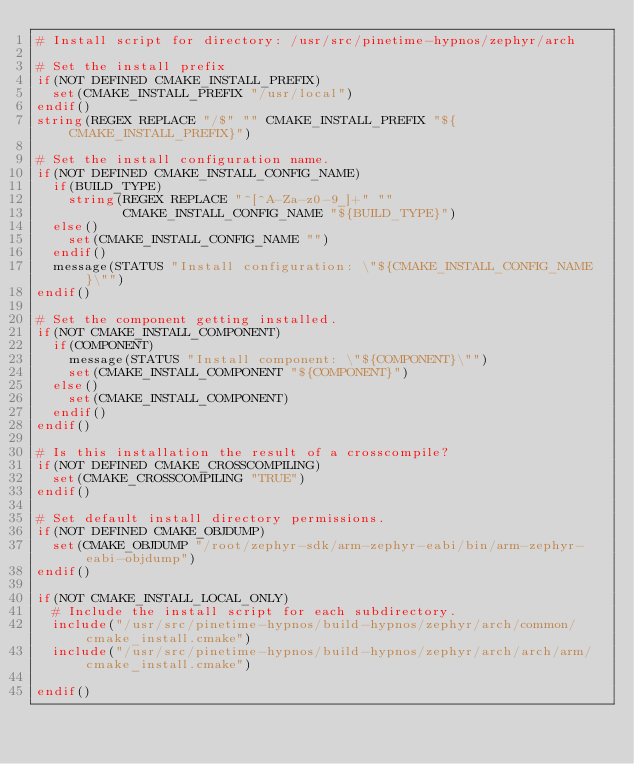<code> <loc_0><loc_0><loc_500><loc_500><_CMake_># Install script for directory: /usr/src/pinetime-hypnos/zephyr/arch

# Set the install prefix
if(NOT DEFINED CMAKE_INSTALL_PREFIX)
  set(CMAKE_INSTALL_PREFIX "/usr/local")
endif()
string(REGEX REPLACE "/$" "" CMAKE_INSTALL_PREFIX "${CMAKE_INSTALL_PREFIX}")

# Set the install configuration name.
if(NOT DEFINED CMAKE_INSTALL_CONFIG_NAME)
  if(BUILD_TYPE)
    string(REGEX REPLACE "^[^A-Za-z0-9_]+" ""
           CMAKE_INSTALL_CONFIG_NAME "${BUILD_TYPE}")
  else()
    set(CMAKE_INSTALL_CONFIG_NAME "")
  endif()
  message(STATUS "Install configuration: \"${CMAKE_INSTALL_CONFIG_NAME}\"")
endif()

# Set the component getting installed.
if(NOT CMAKE_INSTALL_COMPONENT)
  if(COMPONENT)
    message(STATUS "Install component: \"${COMPONENT}\"")
    set(CMAKE_INSTALL_COMPONENT "${COMPONENT}")
  else()
    set(CMAKE_INSTALL_COMPONENT)
  endif()
endif()

# Is this installation the result of a crosscompile?
if(NOT DEFINED CMAKE_CROSSCOMPILING)
  set(CMAKE_CROSSCOMPILING "TRUE")
endif()

# Set default install directory permissions.
if(NOT DEFINED CMAKE_OBJDUMP)
  set(CMAKE_OBJDUMP "/root/zephyr-sdk/arm-zephyr-eabi/bin/arm-zephyr-eabi-objdump")
endif()

if(NOT CMAKE_INSTALL_LOCAL_ONLY)
  # Include the install script for each subdirectory.
  include("/usr/src/pinetime-hypnos/build-hypnos/zephyr/arch/common/cmake_install.cmake")
  include("/usr/src/pinetime-hypnos/build-hypnos/zephyr/arch/arch/arm/cmake_install.cmake")

endif()

</code> 